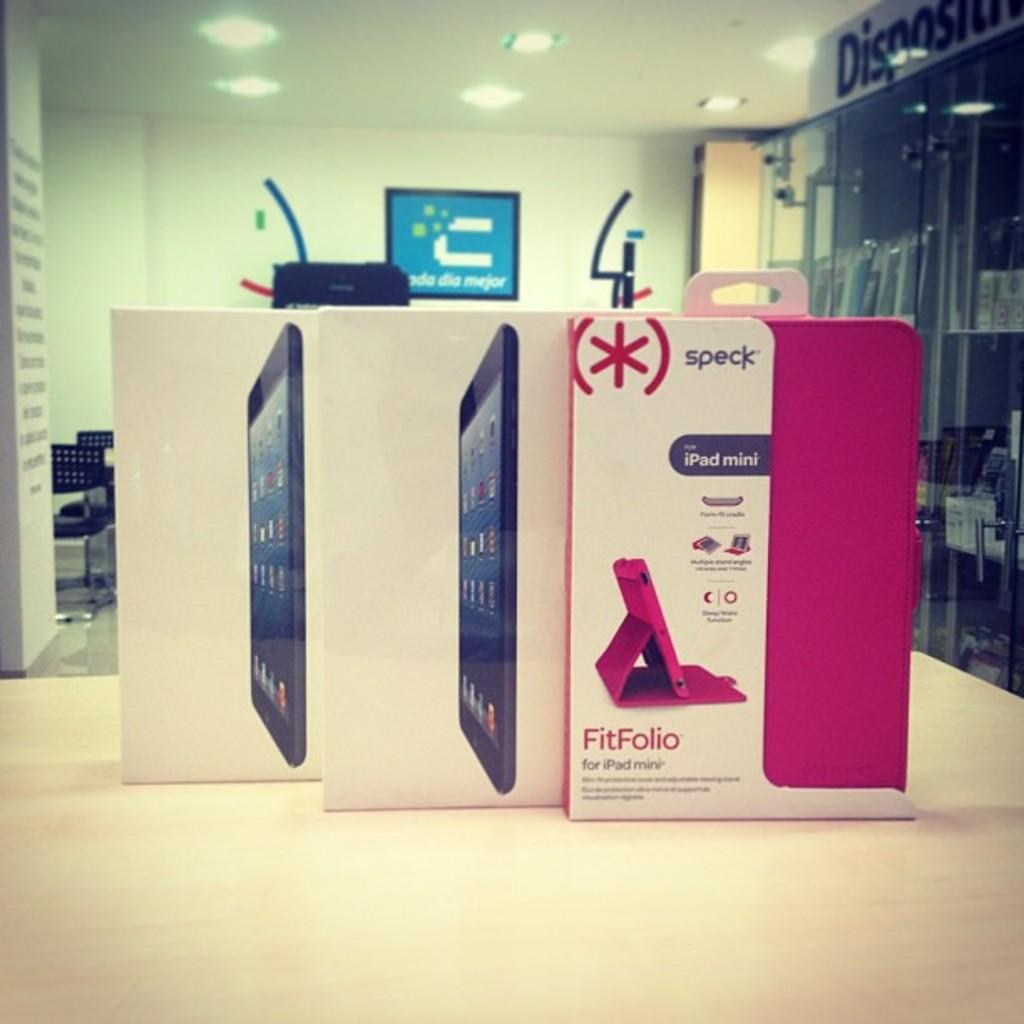<image>
Write a terse but informative summary of the picture. A box for a case for an iPad min is shown in pink with the brand name speck. 